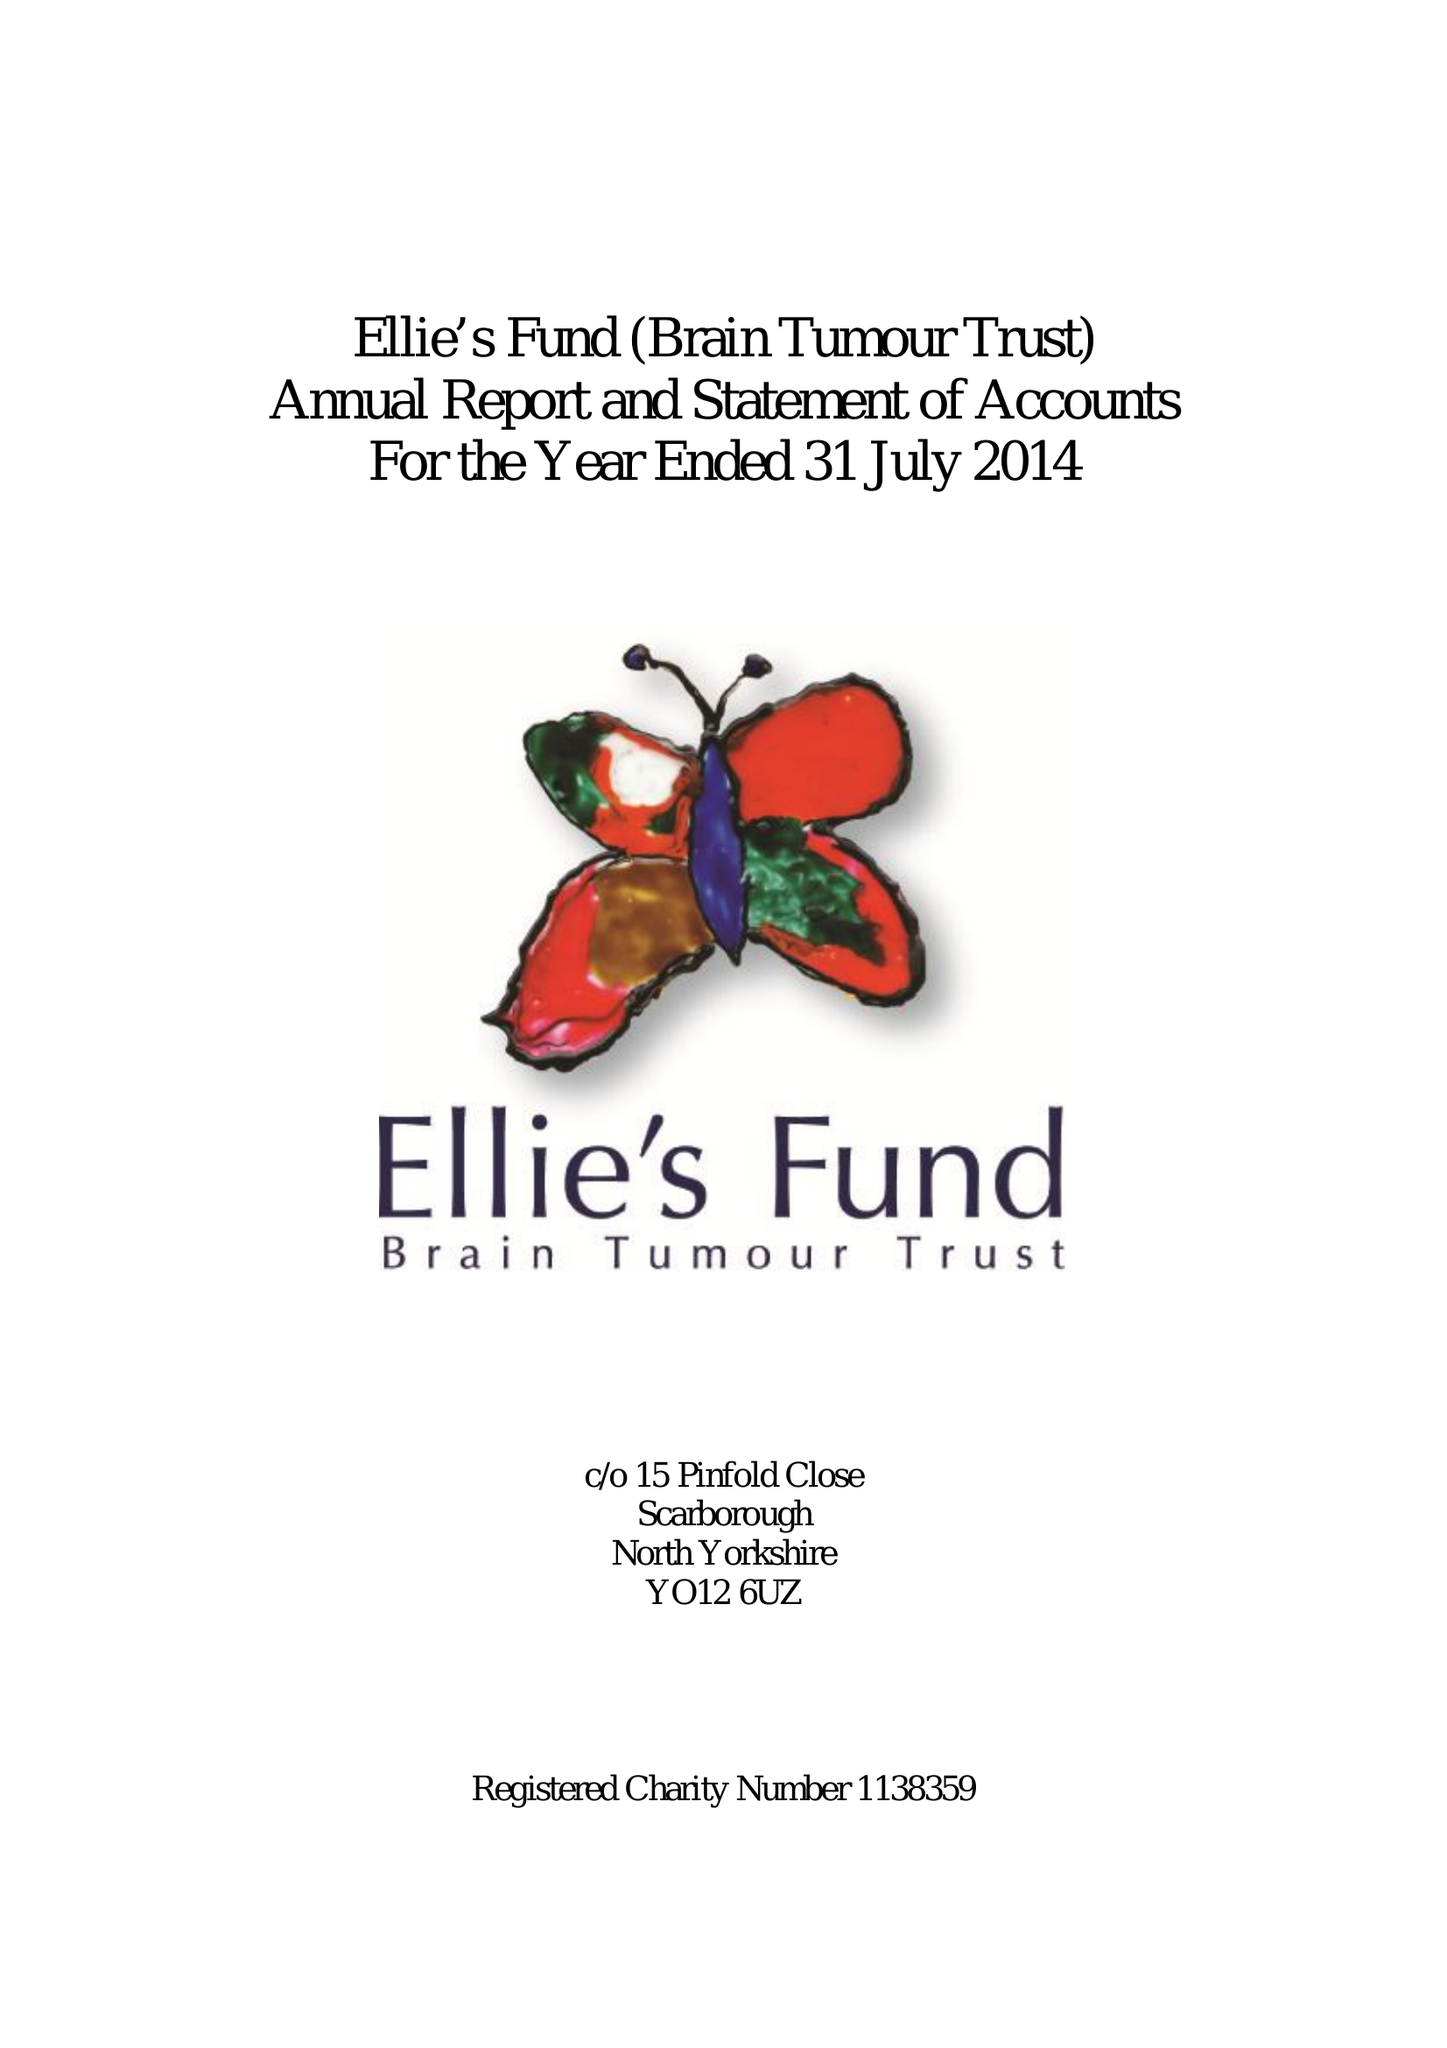What is the value for the report_date?
Answer the question using a single word or phrase. 2014-07-31 